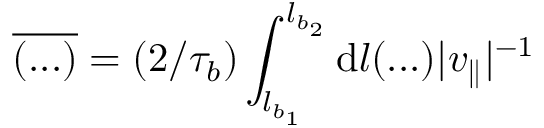Convert formula to latex. <formula><loc_0><loc_0><loc_500><loc_500>\overline { ( \dots ) } = ( 2 / \tau _ { b } ) \int _ { l _ { b _ { 1 } } } ^ { l _ { b _ { 2 } } } d l ( \dots ) | v _ { \| } | ^ { - 1 }</formula> 